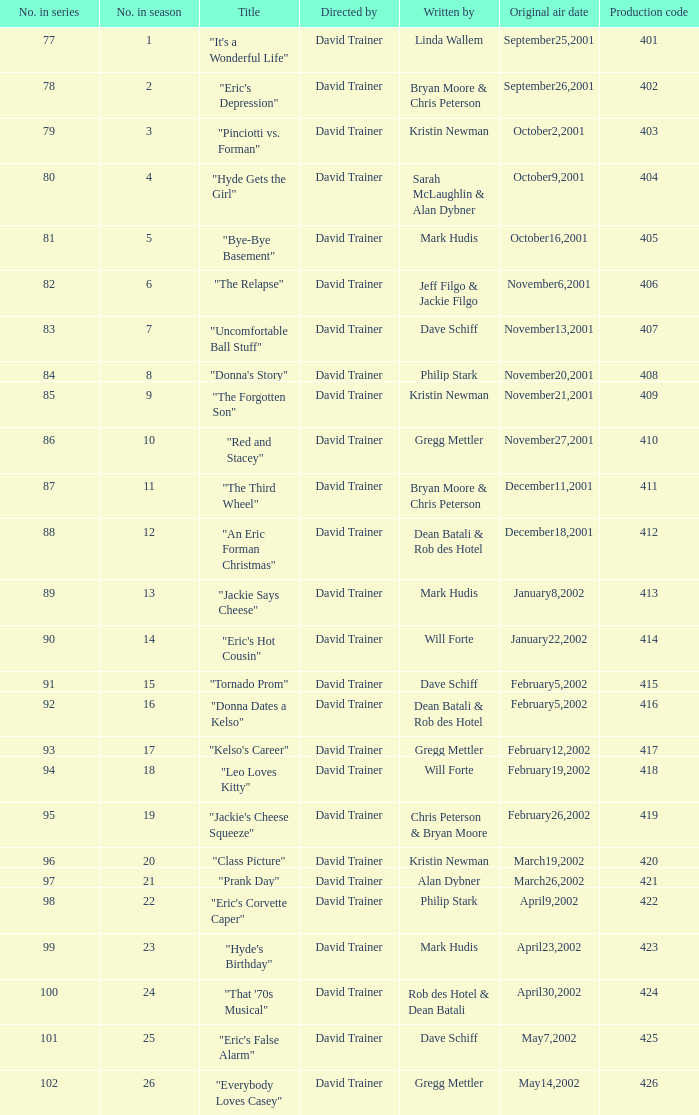How many production codes had a total number in the season of 8? 1.0. 